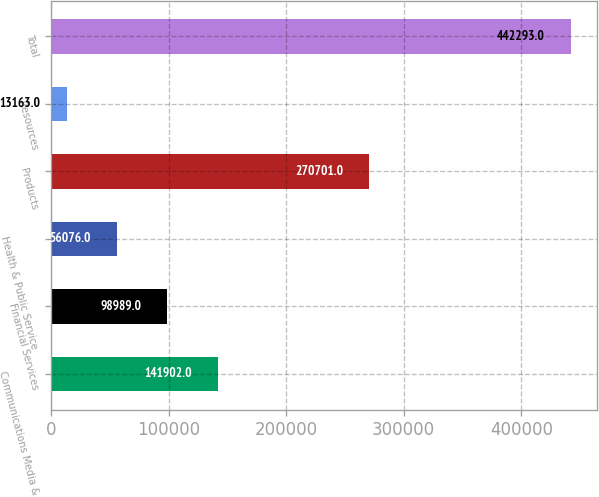Convert chart. <chart><loc_0><loc_0><loc_500><loc_500><bar_chart><fcel>Communications Media &<fcel>Financial Services<fcel>Health & Public Service<fcel>Products<fcel>Resources<fcel>Total<nl><fcel>141902<fcel>98989<fcel>56076<fcel>270701<fcel>13163<fcel>442293<nl></chart> 